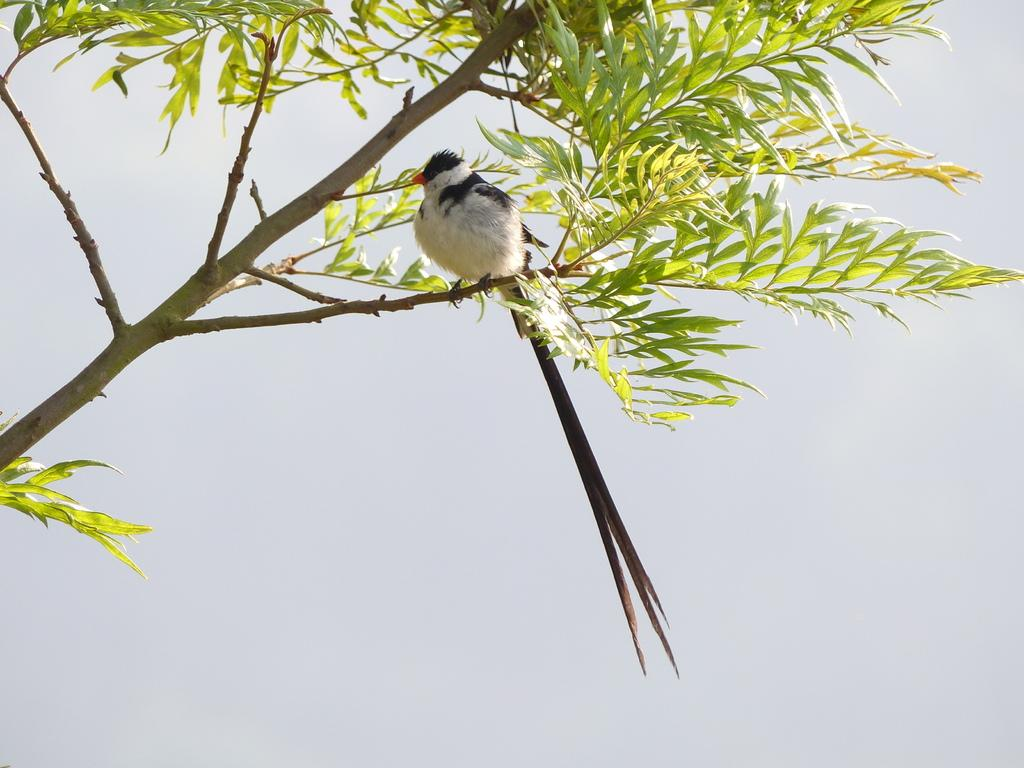What type of animal can be seen in the image? There is a bird in the image. Where is the bird located? The bird is standing on a branch of a tree. What color is the background of the image? The background of the image is white. What type of house can be seen in the background of the image? There is no house present in the image; the background is white. 